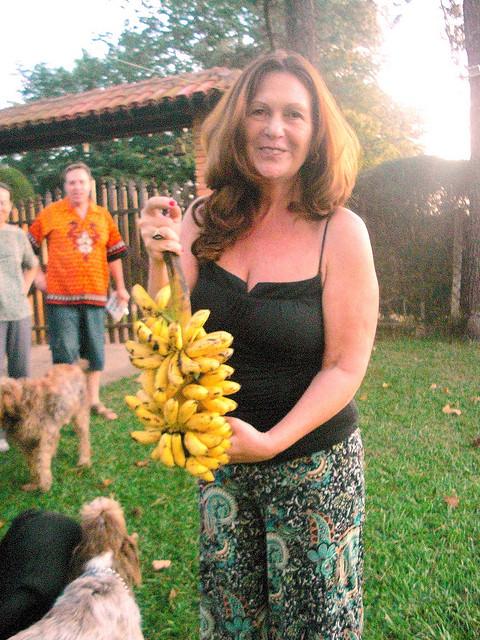Can the lady eat all those bananas at once?
Keep it brief. No. Does this lady look happy about the bananas?
Quick response, please. Yes. What color shirt is the man on the left wearing?
Give a very brief answer. Orange. 